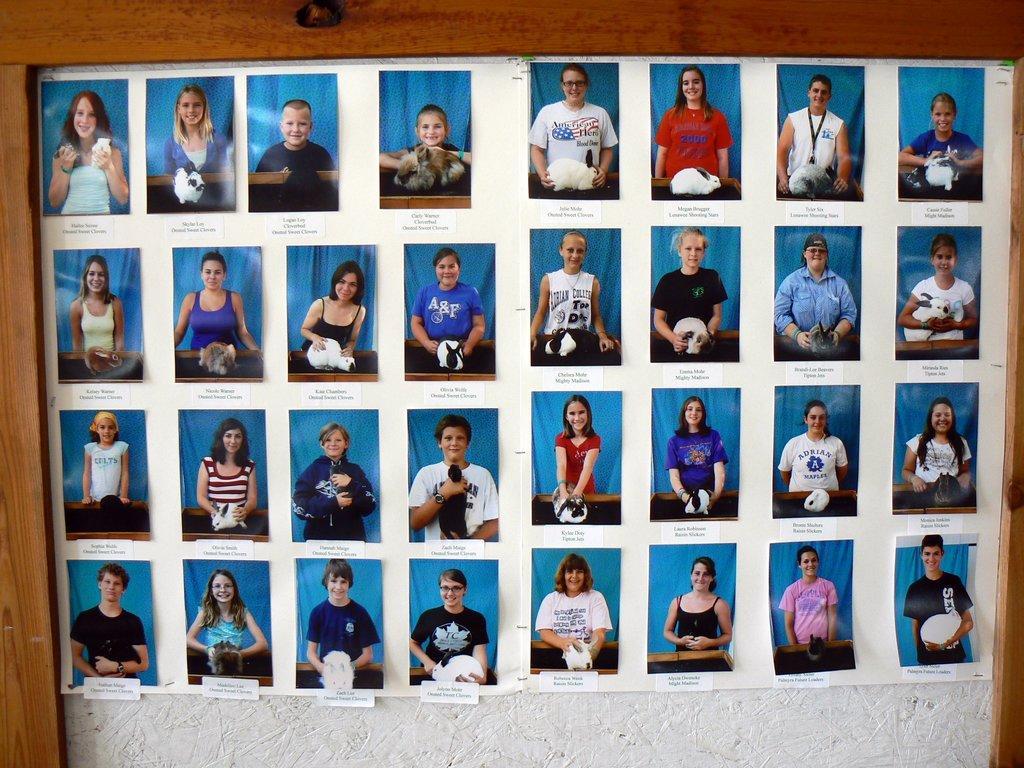Describe this image in one or two sentences. In this picture we can see some collage photographs of men and women, placed on the white board. 